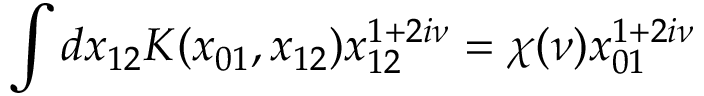<formula> <loc_0><loc_0><loc_500><loc_500>\int d x _ { 1 2 } K ( x _ { 0 1 } , x _ { 1 2 } ) x _ { 1 2 } ^ { 1 + 2 i \nu } = \chi ( \nu ) x _ { 0 1 } ^ { 1 + 2 i \nu }</formula> 